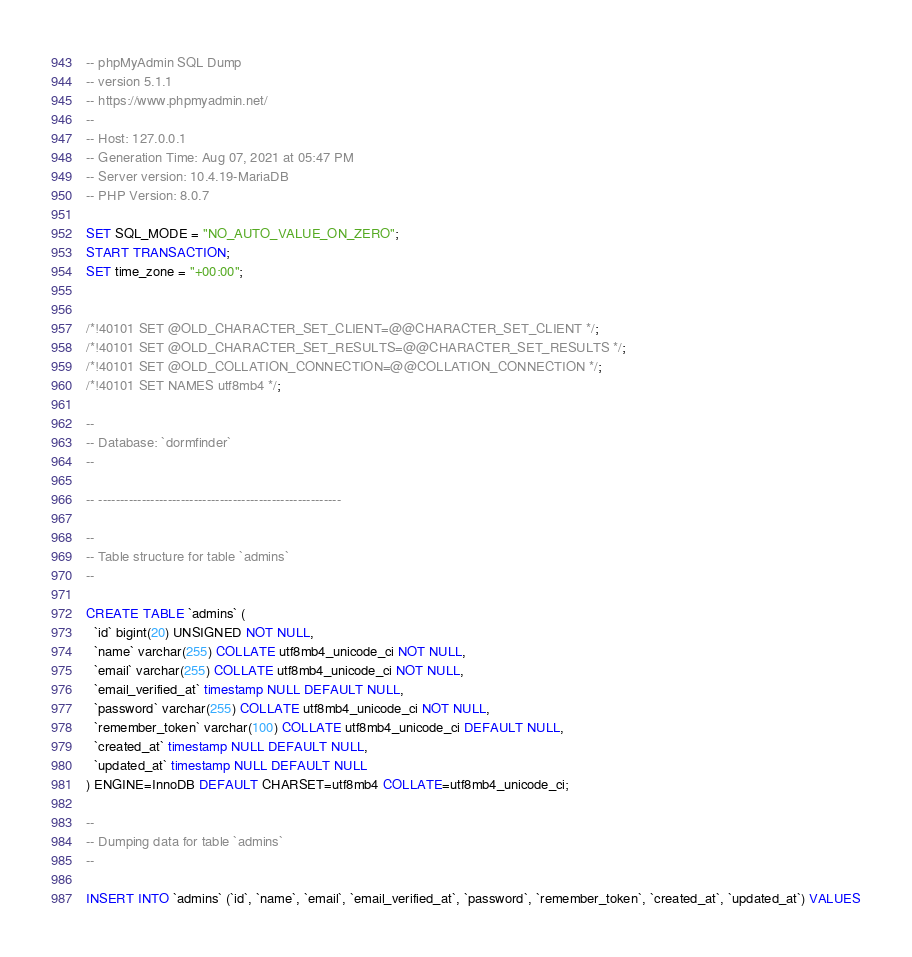Convert code to text. <code><loc_0><loc_0><loc_500><loc_500><_SQL_>-- phpMyAdmin SQL Dump
-- version 5.1.1
-- https://www.phpmyadmin.net/
--
-- Host: 127.0.0.1
-- Generation Time: Aug 07, 2021 at 05:47 PM
-- Server version: 10.4.19-MariaDB
-- PHP Version: 8.0.7

SET SQL_MODE = "NO_AUTO_VALUE_ON_ZERO";
START TRANSACTION;
SET time_zone = "+00:00";


/*!40101 SET @OLD_CHARACTER_SET_CLIENT=@@CHARACTER_SET_CLIENT */;
/*!40101 SET @OLD_CHARACTER_SET_RESULTS=@@CHARACTER_SET_RESULTS */;
/*!40101 SET @OLD_COLLATION_CONNECTION=@@COLLATION_CONNECTION */;
/*!40101 SET NAMES utf8mb4 */;

--
-- Database: `dormfinder`
--

-- --------------------------------------------------------

--
-- Table structure for table `admins`
--

CREATE TABLE `admins` (
  `id` bigint(20) UNSIGNED NOT NULL,
  `name` varchar(255) COLLATE utf8mb4_unicode_ci NOT NULL,
  `email` varchar(255) COLLATE utf8mb4_unicode_ci NOT NULL,
  `email_verified_at` timestamp NULL DEFAULT NULL,
  `password` varchar(255) COLLATE utf8mb4_unicode_ci NOT NULL,
  `remember_token` varchar(100) COLLATE utf8mb4_unicode_ci DEFAULT NULL,
  `created_at` timestamp NULL DEFAULT NULL,
  `updated_at` timestamp NULL DEFAULT NULL
) ENGINE=InnoDB DEFAULT CHARSET=utf8mb4 COLLATE=utf8mb4_unicode_ci;

--
-- Dumping data for table `admins`
--

INSERT INTO `admins` (`id`, `name`, `email`, `email_verified_at`, `password`, `remember_token`, `created_at`, `updated_at`) VALUES</code> 